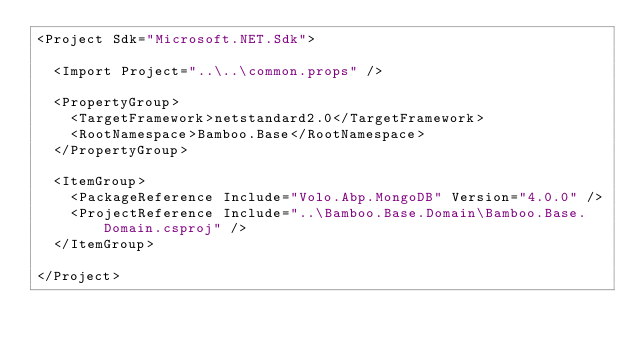<code> <loc_0><loc_0><loc_500><loc_500><_XML_><Project Sdk="Microsoft.NET.Sdk">

  <Import Project="..\..\common.props" />

  <PropertyGroup>
    <TargetFramework>netstandard2.0</TargetFramework>
    <RootNamespace>Bamboo.Base</RootNamespace>
  </PropertyGroup>

  <ItemGroup>
    <PackageReference Include="Volo.Abp.MongoDB" Version="4.0.0" />
    <ProjectReference Include="..\Bamboo.Base.Domain\Bamboo.Base.Domain.csproj" />
  </ItemGroup>

</Project>
</code> 